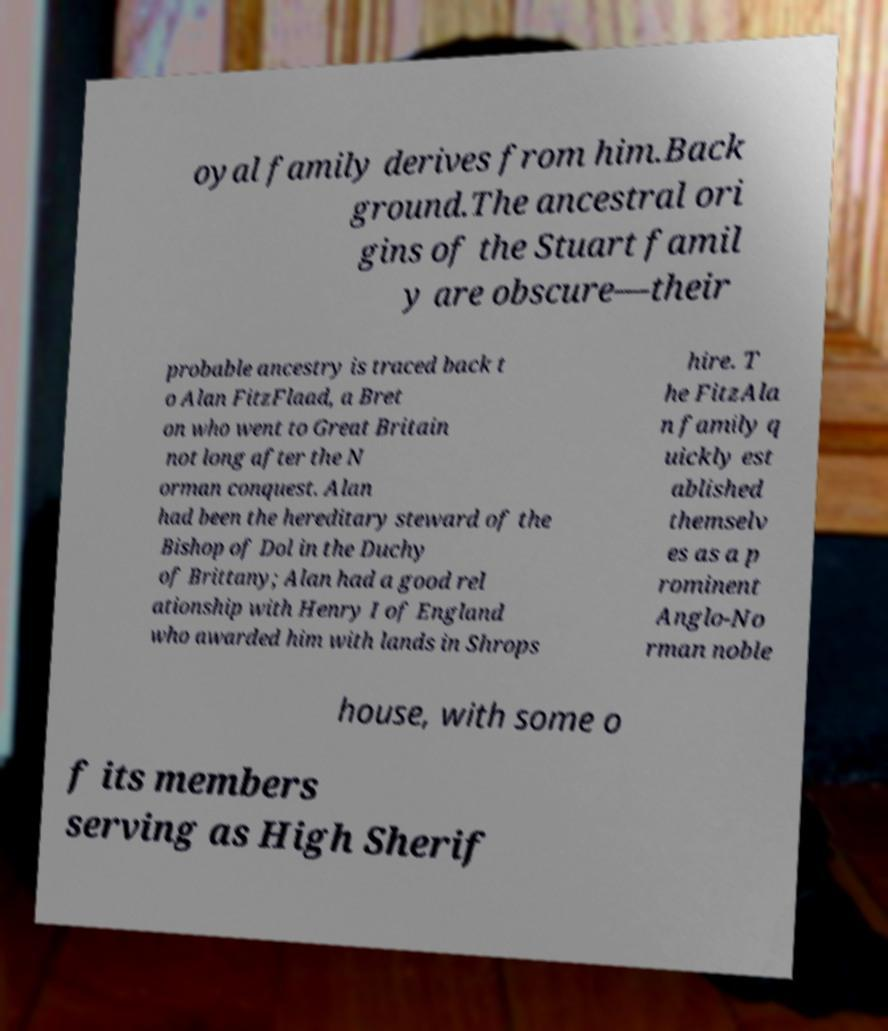I need the written content from this picture converted into text. Can you do that? oyal family derives from him.Back ground.The ancestral ori gins of the Stuart famil y are obscure—their probable ancestry is traced back t o Alan FitzFlaad, a Bret on who went to Great Britain not long after the N orman conquest. Alan had been the hereditary steward of the Bishop of Dol in the Duchy of Brittany; Alan had a good rel ationship with Henry I of England who awarded him with lands in Shrops hire. T he FitzAla n family q uickly est ablished themselv es as a p rominent Anglo-No rman noble house, with some o f its members serving as High Sherif 